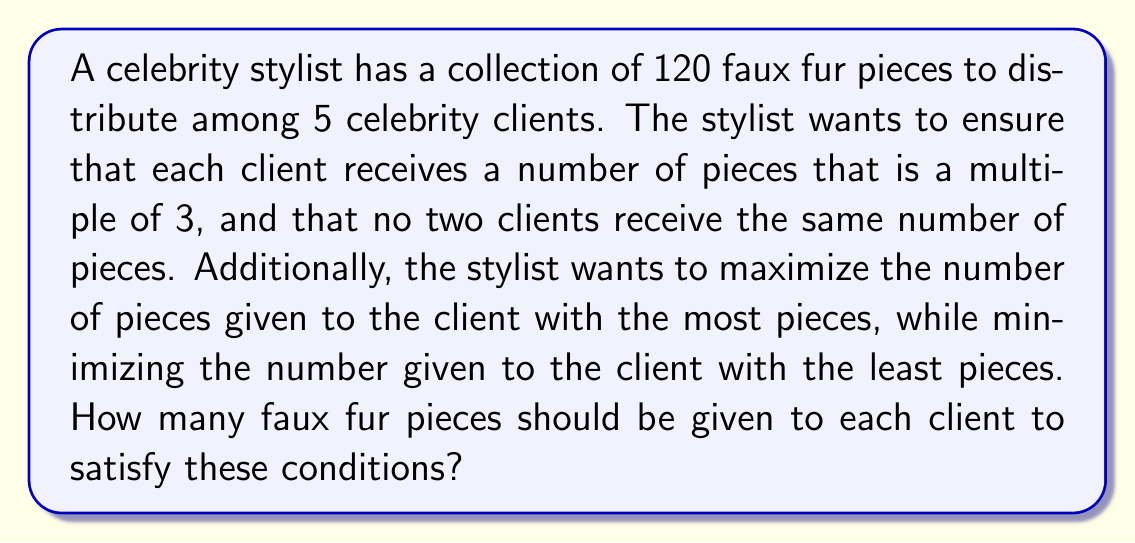Solve this math problem. Let's approach this step-by-step using concepts from Ring theory:

1) First, we need to find the possible distributions that are multiples of 3 and sum to 120:

   $$120 = 3x_1 + 3x_2 + 3x_3 + 3x_4 + 3x_5$$
   $$40 = x_1 + x_2 + x_3 + x_4 + x_5$$

2) We need five different multiples of 3 that sum to 120. Let's start with the smallest possible multiples:

   3, 6, 9, 12, 15, 18, 21, 24, 27, 30, 33, 36, ...

3) To maximize the difference between the largest and smallest numbers, we should use a combination of small and large numbers.

4) After some trial and error, we find that the following combination works:
   
   $$3 + 15 + 24 + 33 + 45 = 120$$

5) This satisfies all our conditions:
   - Each number is a multiple of 3
   - All numbers are different
   - They sum to 120
   - The difference between the largest (45) and smallest (3) is maximized

6) Therefore, the optimal distribution is 3, 15, 24, 33, and 45 faux fur pieces.
Answer: The optimal distribution is 3, 15, 24, 33, and 45 faux fur pieces to the five celebrity clients. 